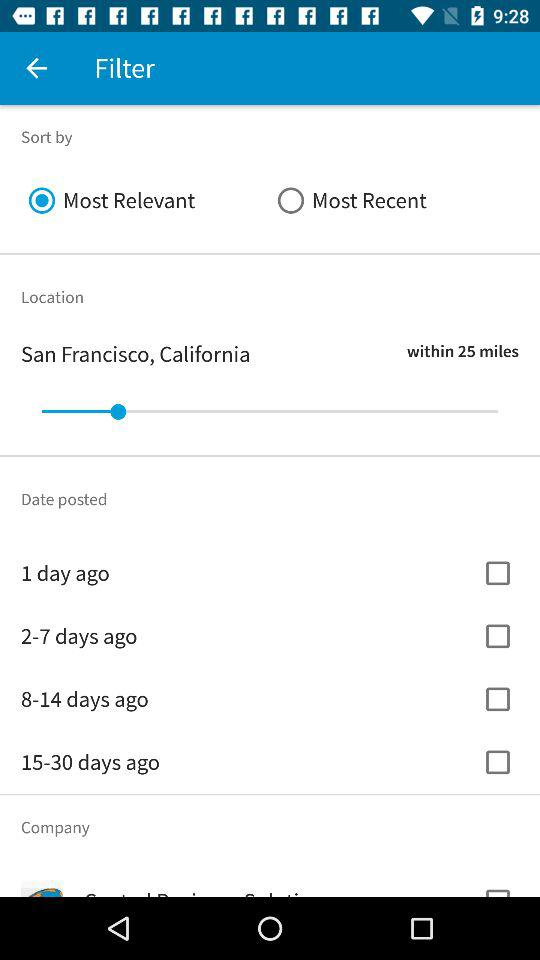What is the location? The location is San Francisco, California. 